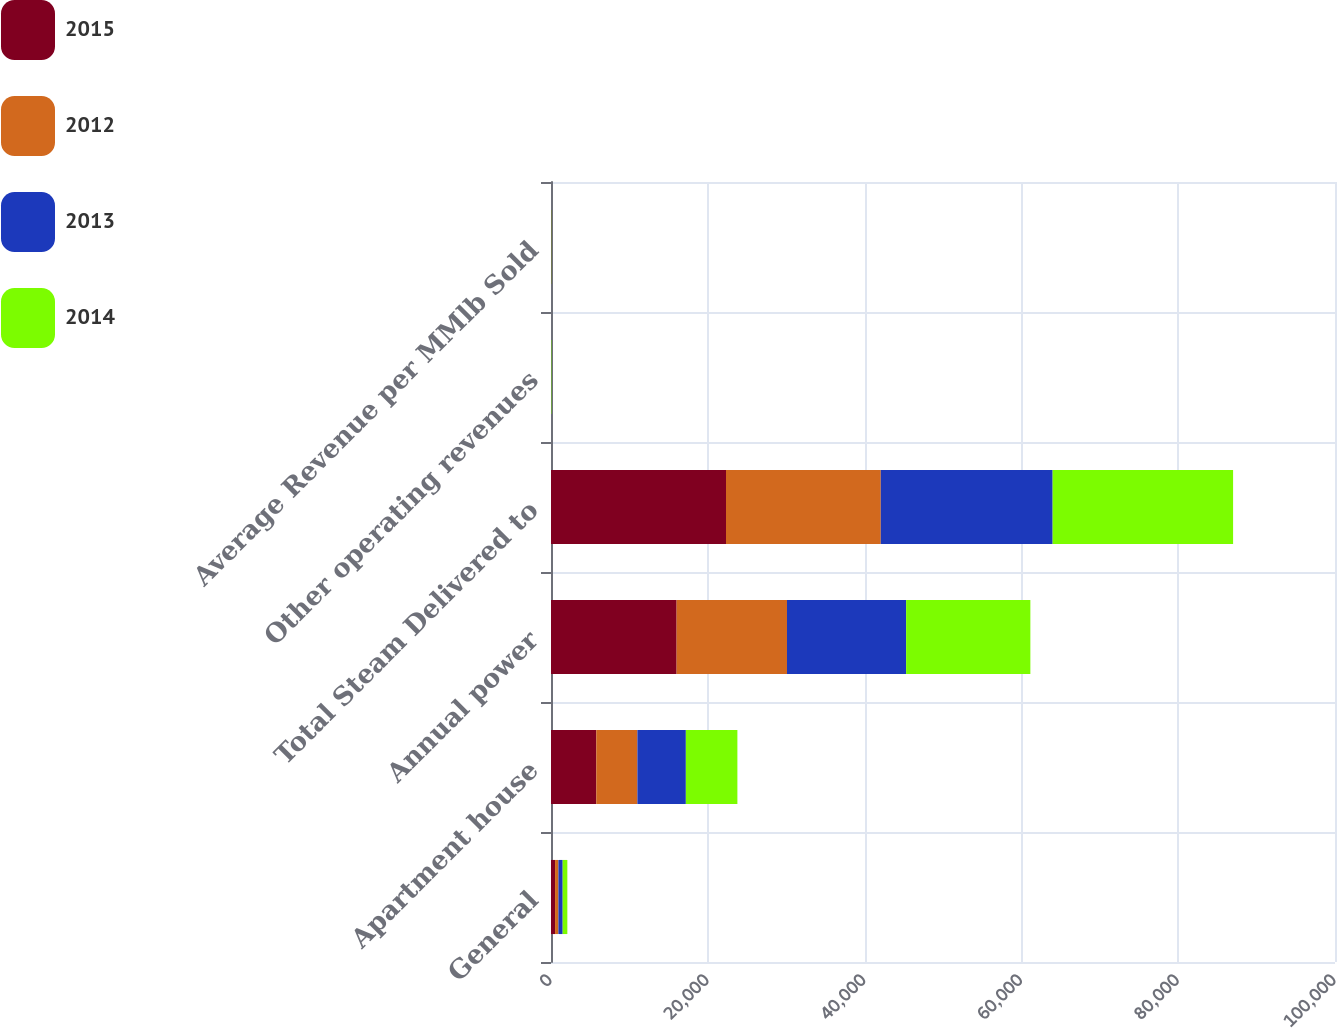Convert chart to OTSL. <chart><loc_0><loc_0><loc_500><loc_500><stacked_bar_chart><ecel><fcel>General<fcel>Apartment house<fcel>Annual power<fcel>Total Steam Delivered to<fcel>Other operating revenues<fcel>Average Revenue per MMlb Sold<nl><fcel>2015<fcel>519<fcel>5779<fcel>16024<fcel>22322<fcel>7<fcel>30.91<nl><fcel>2012<fcel>425<fcel>5240<fcel>14076<fcel>19741<fcel>16<fcel>31<nl><fcel>2013<fcel>547<fcel>6181<fcel>15195<fcel>21923<fcel>26<fcel>32.34<nl><fcel>2014<fcel>594<fcel>6574<fcel>15848<fcel>23016<fcel>51<fcel>29.5<nl></chart> 